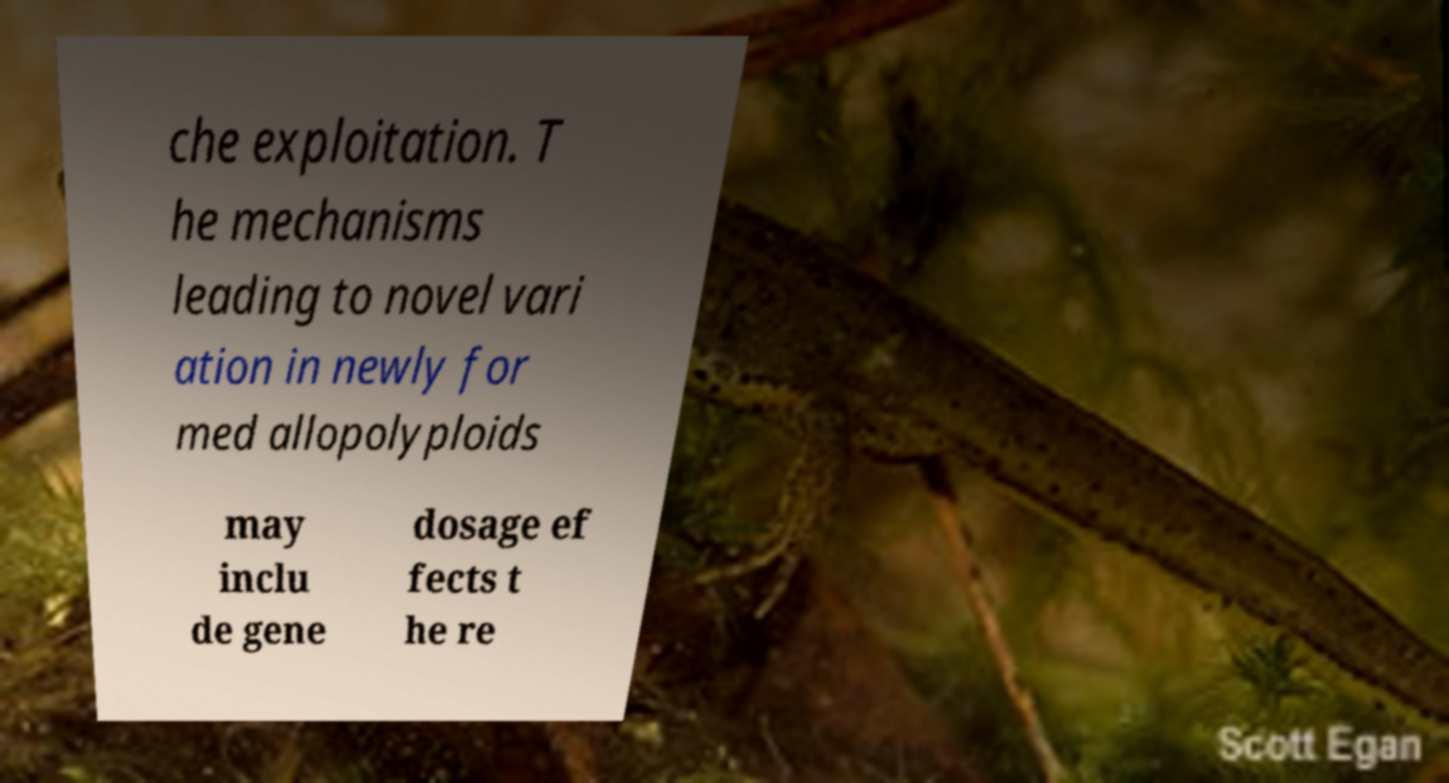Could you assist in decoding the text presented in this image and type it out clearly? che exploitation. T he mechanisms leading to novel vari ation in newly for med allopolyploids may inclu de gene dosage ef fects t he re 